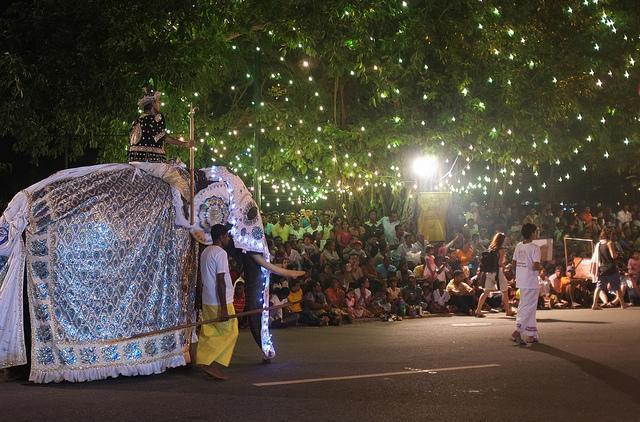Which part of the animal is precious?
Select the accurate answer and provide justification: `Answer: choice
Rationale: srationale.`
Options: Ivory, skin, nose, cape. Answer: ivory.
Rationale: The elephant has tusks made of ivory that are worth a lot of money. 